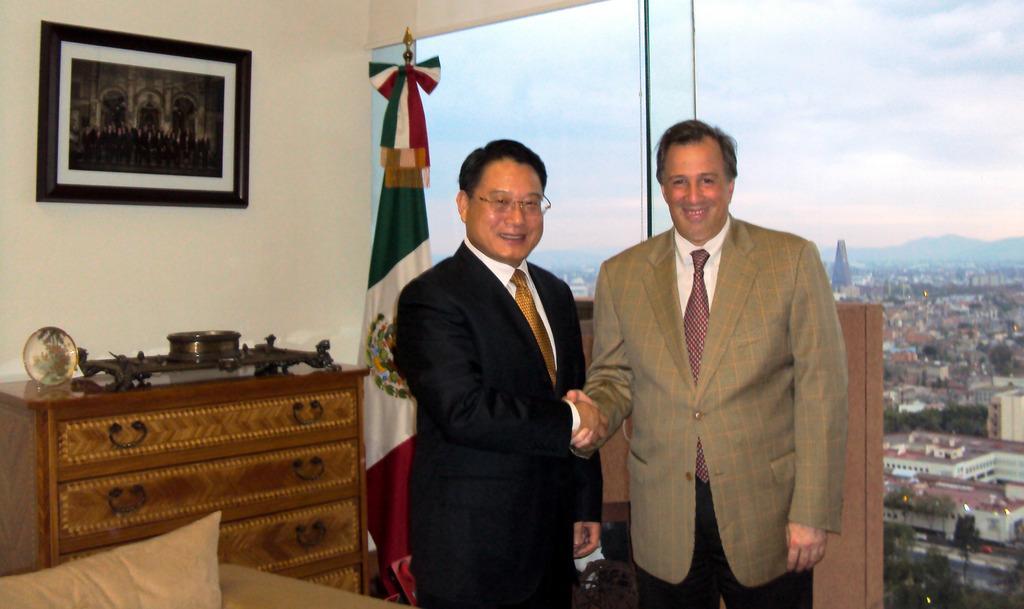Could you give a brief overview of what you see in this image? In this image I can see 2 men in suit and tie. I can also see a flag, cupboard and a photo frame on this wall. In the background I can see number of buildings and clear view of sky. 